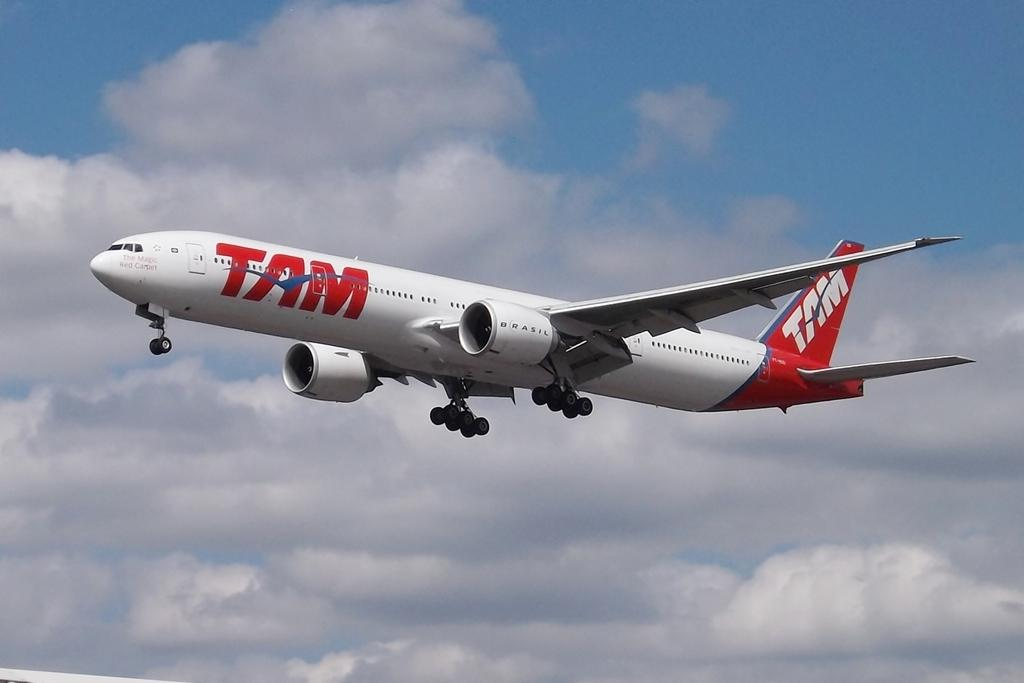<image>
Share a concise interpretation of the image provided. A red and white airplane in mid flight with the TAM logo on the side. 